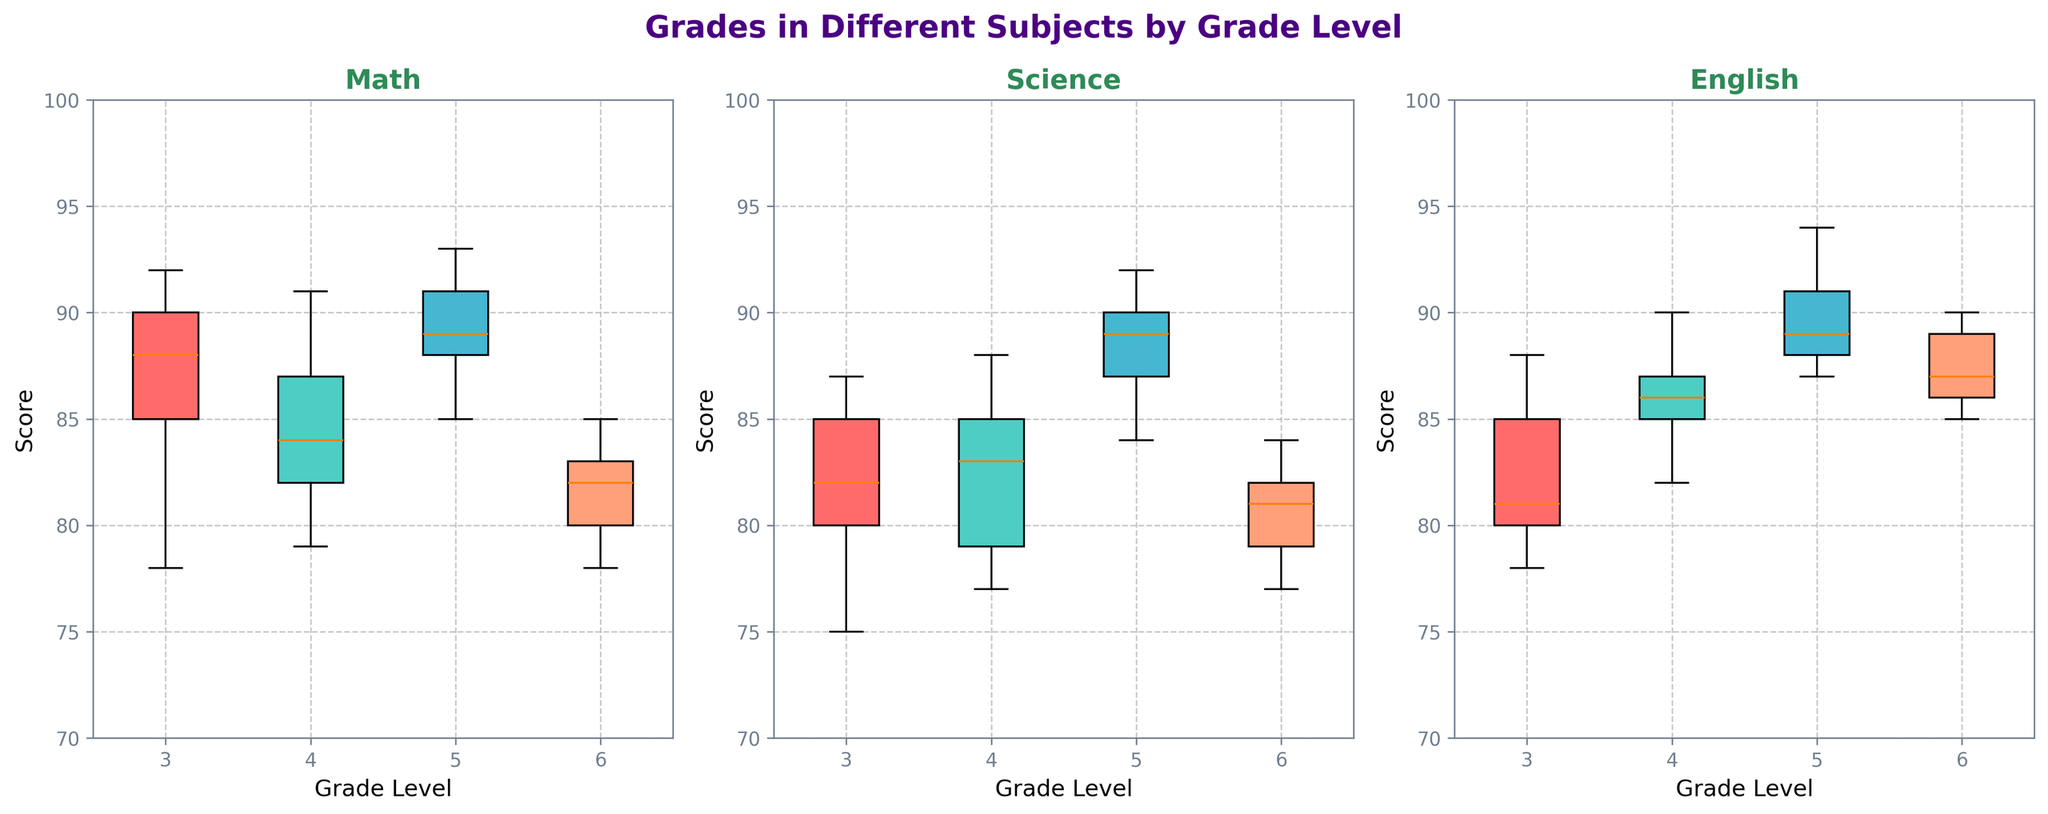What is the title of the figure? The title of the figure is found at the top and describes what the visual represents.
Answer: Grades in Different Subjects by Grade Level What is the color of the box for Math in grade 6? The color of the box for Math in grade 6 can be identified by looking at the box plot in the Math subplot.
Answer: Red Which grade level has the highest median score in English? To determine the highest median score in English, look at the middle line inside each box in the English subplot.
Answer: Grade 5 Which subject shows the greatest range in scores for grade 3? The range can be identified by looking at the distance between the top and bottom whiskers in the grade 3 box plots for each subject.
Answer: Math What is the median score for Science in grade 4? The median score is the middle line inside the box for Science in grade 4.
Answer: 83 Which subject has the most consistent scores across all grades? The consistency of scores can be determined by looking at the spread of the box plots across all grades. A smaller spread indicates higher consistency.
Answer: English What is the interquartile range (IQR) for grades in Math for grade 5? The interquartile range (IQR) is calculated by subtracting the lower quartile (bottom of the box) from the upper quartile (top of the box) in the Math box plot for grade 5.
Answer: 4 Which subject for grade 6 has the highest upper whisker value? To find the subject with the highest upper whisker value for grade 6, compare the top end of the whiskers for each subject.
Answer: English How does the median score for Math in grade 5 compare to the median score for Science in grade 5? Compare the middle lines inside the boxes for Math and Science in the grade 5 subplots to see which is higher.
Answer: Math is higher 